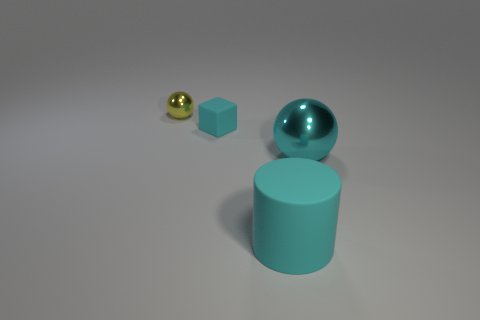What is the shape of the big metal object that is the same color as the big matte thing?
Keep it short and to the point. Sphere. Is the number of yellow metallic objects greater than the number of big blue rubber objects?
Give a very brief answer. Yes. There is a metal ball that is behind the big cyan metal sphere; what is its color?
Your answer should be compact. Yellow. Is the number of small shiny spheres on the left side of the tiny metal ball greater than the number of tiny yellow metal balls?
Ensure brevity in your answer.  No. Do the large cyan cylinder and the small yellow sphere have the same material?
Your answer should be very brief. No. How many other things are the same shape as the tiny yellow object?
Offer a terse response. 1. Is there any other thing that has the same material as the yellow ball?
Offer a terse response. Yes. There is a large thing on the right side of the large cyan object left of the ball that is in front of the tiny yellow metal sphere; what is its color?
Your response must be concise. Cyan. Does the big cyan thing that is to the right of the large cyan rubber thing have the same shape as the big rubber object?
Make the answer very short. No. How many small cyan matte objects are there?
Your answer should be compact. 1. 